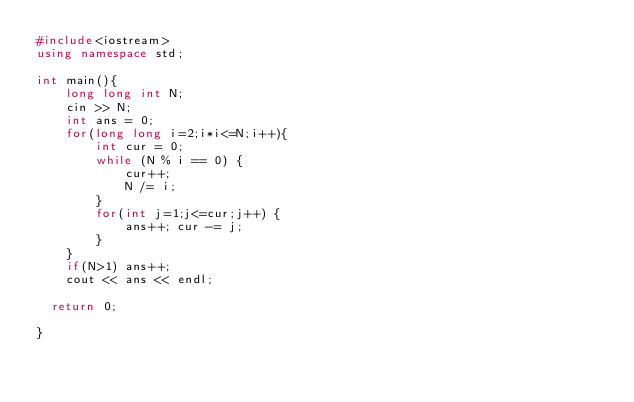Convert code to text. <code><loc_0><loc_0><loc_500><loc_500><_C++_>#include<iostream>
using namespace std;

int main(){
    long long int N;
    cin >> N;
    int ans = 0;
    for(long long i=2;i*i<=N;i++){
        int cur = 0;
        while (N % i == 0) {
            cur++;
            N /= i;
        }
        for(int j=1;j<=cur;j++) {
            ans++; cur -= j;
        }
    }
    if(N>1) ans++;
    cout << ans << endl;

	return 0;
   
}</code> 